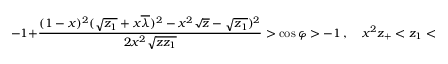Convert formula to latex. <formula><loc_0><loc_0><loc_500><loc_500>- 1 + \frac { ( 1 - x ) ^ { 2 } ( \sqrt { z _ { 1 } } + x \overline { \lambda } ) ^ { 2 } - x ^ { 2 } \sqrt { z } - \sqrt { z _ { 1 } } ) ^ { 2 } } { 2 x ^ { 2 } \sqrt { z z _ { 1 } } } > \cos \varphi > - 1 \ , \quad x ^ { 2 } z _ { + } < z _ { 1 } < x ^ { 2 } J _ { + } ^ { 2 } \ ,</formula> 